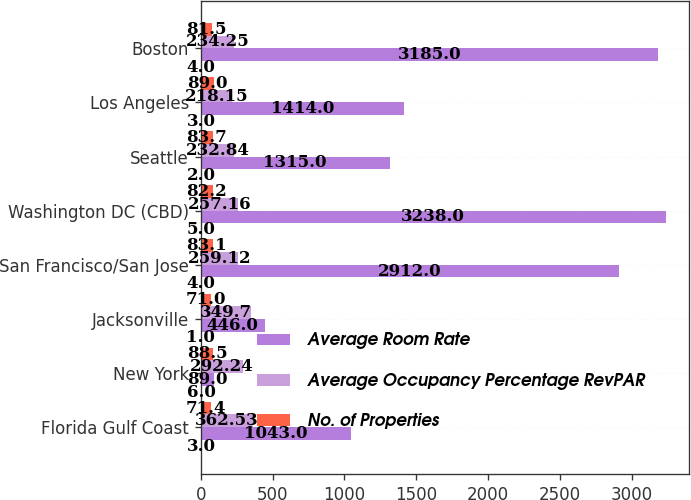Convert chart. <chart><loc_0><loc_0><loc_500><loc_500><stacked_bar_chart><ecel><fcel>Florida Gulf Coast<fcel>New York<fcel>Jacksonville<fcel>San Francisco/San Jose<fcel>Washington DC (CBD)<fcel>Seattle<fcel>Los Angeles<fcel>Boston<nl><fcel>nan<fcel>3<fcel>6<fcel>1<fcel>4<fcel>5<fcel>2<fcel>3<fcel>4<nl><fcel>Average Room Rate<fcel>1043<fcel>89<fcel>446<fcel>2912<fcel>3238<fcel>1315<fcel>1414<fcel>3185<nl><fcel>Average Occupancy Percentage RevPAR<fcel>362.53<fcel>292.24<fcel>349.7<fcel>259.12<fcel>257.16<fcel>232.84<fcel>218.15<fcel>234.25<nl><fcel>No. of Properties<fcel>71.4<fcel>88.5<fcel>71<fcel>83.1<fcel>82.2<fcel>83.7<fcel>89<fcel>81.5<nl></chart> 